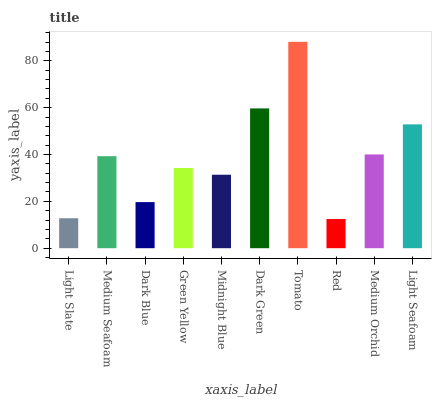Is Red the minimum?
Answer yes or no. Yes. Is Tomato the maximum?
Answer yes or no. Yes. Is Medium Seafoam the minimum?
Answer yes or no. No. Is Medium Seafoam the maximum?
Answer yes or no. No. Is Medium Seafoam greater than Light Slate?
Answer yes or no. Yes. Is Light Slate less than Medium Seafoam?
Answer yes or no. Yes. Is Light Slate greater than Medium Seafoam?
Answer yes or no. No. Is Medium Seafoam less than Light Slate?
Answer yes or no. No. Is Medium Seafoam the high median?
Answer yes or no. Yes. Is Green Yellow the low median?
Answer yes or no. Yes. Is Medium Orchid the high median?
Answer yes or no. No. Is Midnight Blue the low median?
Answer yes or no. No. 